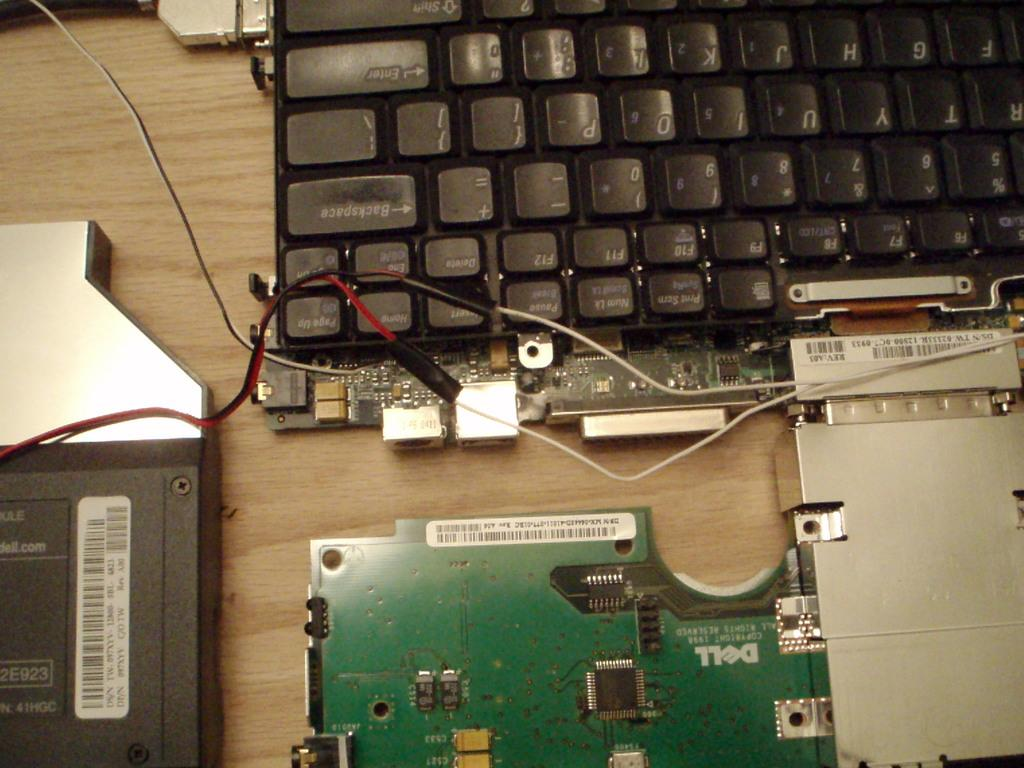What objects are present in the image that are related to technology? There are devices and a keyboard in the image. Where are the devices and keyboard located? The devices and keyboard are placed on a table. What type of bait is being used to attract fish in the image? There is no bait or fishing activity present in the image. How is the milk being used in the image? There is no milk present in the image. 